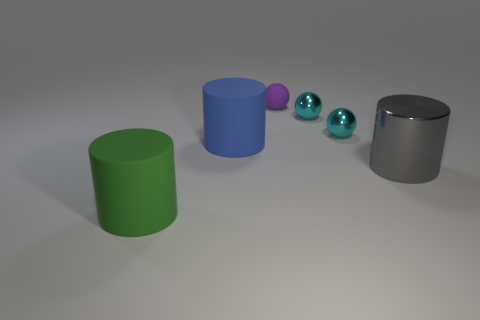Do the purple object and the large blue thing have the same shape?
Your answer should be very brief. No. What is the shape of the large object that is to the left of the big cylinder behind the large cylinder on the right side of the small purple rubber sphere?
Give a very brief answer. Cylinder. Does the large object that is to the right of the tiny purple matte ball have the same shape as the big matte thing that is behind the green thing?
Your response must be concise. Yes. Are there any tiny things that have the same material as the large gray cylinder?
Your answer should be very brief. Yes. What is the color of the big cylinder that is in front of the metallic object that is in front of the large blue cylinder that is behind the green matte object?
Give a very brief answer. Green. Do the large cylinder that is in front of the big gray object and the large thing that is right of the blue cylinder have the same material?
Your answer should be very brief. No. There is a large rubber object behind the big green thing; what is its shape?
Keep it short and to the point. Cylinder. What number of objects are either large gray rubber things or cylinders that are right of the tiny purple rubber object?
Your answer should be compact. 1. Do the small purple object and the green object have the same material?
Your response must be concise. Yes. Are there the same number of gray metallic objects in front of the big gray metal cylinder and large blue matte cylinders in front of the green cylinder?
Your answer should be very brief. Yes. 